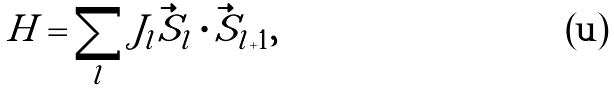Convert formula to latex. <formula><loc_0><loc_0><loc_500><loc_500>H = \sum _ { l } J _ { l } \vec { S } _ { l } \cdot \vec { S } _ { l + 1 } ,</formula> 